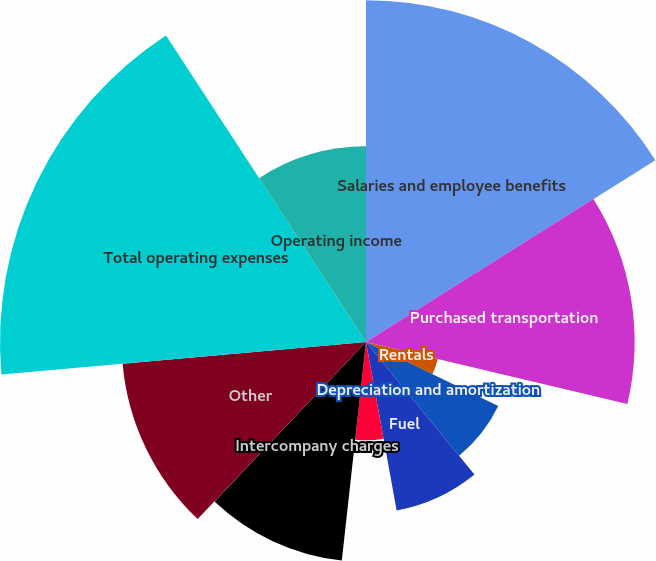Convert chart. <chart><loc_0><loc_0><loc_500><loc_500><pie_chart><fcel>Salaries and employee benefits<fcel>Purchased transportation<fcel>Rentals<fcel>Depreciation and amortization<fcel>Fuel<fcel>Maintenance and repairs<fcel>Intercompany charges<fcel>Other<fcel>Total operating expenses<fcel>Operating income<nl><fcel>16.07%<fcel>12.63%<fcel>3.47%<fcel>6.91%<fcel>8.05%<fcel>4.62%<fcel>10.34%<fcel>11.49%<fcel>17.21%<fcel>9.2%<nl></chart> 